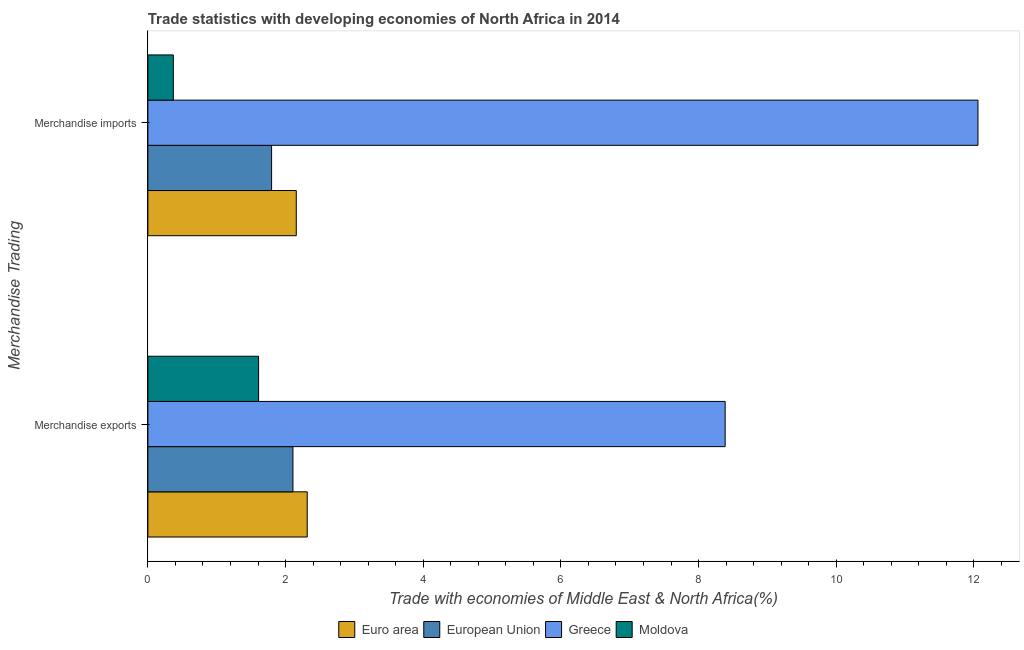How many groups of bars are there?
Offer a terse response. 2. Are the number of bars on each tick of the Y-axis equal?
Your response must be concise. Yes. How many bars are there on the 2nd tick from the bottom?
Offer a terse response. 4. What is the label of the 1st group of bars from the top?
Make the answer very short. Merchandise imports. What is the merchandise exports in European Union?
Your answer should be compact. 2.11. Across all countries, what is the maximum merchandise exports?
Provide a succinct answer. 8.39. Across all countries, what is the minimum merchandise exports?
Provide a short and direct response. 1.61. In which country was the merchandise exports minimum?
Give a very brief answer. Moldova. What is the total merchandise exports in the graph?
Keep it short and to the point. 14.42. What is the difference between the merchandise exports in Moldova and that in Greece?
Ensure brevity in your answer.  -6.78. What is the difference between the merchandise imports in Euro area and the merchandise exports in Moldova?
Keep it short and to the point. 0.55. What is the average merchandise exports per country?
Provide a succinct answer. 3.6. What is the difference between the merchandise imports and merchandise exports in European Union?
Make the answer very short. -0.31. In how many countries, is the merchandise exports greater than 0.8 %?
Provide a short and direct response. 4. What is the ratio of the merchandise exports in European Union to that in Moldova?
Make the answer very short. 1.31. Is the merchandise exports in Greece less than that in European Union?
Keep it short and to the point. No. What does the 3rd bar from the top in Merchandise imports represents?
Your response must be concise. European Union. What does the 4th bar from the bottom in Merchandise exports represents?
Give a very brief answer. Moldova. How many bars are there?
Make the answer very short. 8. Are all the bars in the graph horizontal?
Make the answer very short. Yes. What is the difference between two consecutive major ticks on the X-axis?
Give a very brief answer. 2. Are the values on the major ticks of X-axis written in scientific E-notation?
Your answer should be compact. No. Does the graph contain any zero values?
Offer a very short reply. No. Does the graph contain grids?
Make the answer very short. No. Where does the legend appear in the graph?
Provide a succinct answer. Bottom center. What is the title of the graph?
Your answer should be compact. Trade statistics with developing economies of North Africa in 2014. What is the label or title of the X-axis?
Ensure brevity in your answer.  Trade with economies of Middle East & North Africa(%). What is the label or title of the Y-axis?
Offer a terse response. Merchandise Trading. What is the Trade with economies of Middle East & North Africa(%) of Euro area in Merchandise exports?
Give a very brief answer. 2.32. What is the Trade with economies of Middle East & North Africa(%) of European Union in Merchandise exports?
Give a very brief answer. 2.11. What is the Trade with economies of Middle East & North Africa(%) in Greece in Merchandise exports?
Offer a terse response. 8.39. What is the Trade with economies of Middle East & North Africa(%) in Moldova in Merchandise exports?
Offer a terse response. 1.61. What is the Trade with economies of Middle East & North Africa(%) in Euro area in Merchandise imports?
Your answer should be compact. 2.16. What is the Trade with economies of Middle East & North Africa(%) of European Union in Merchandise imports?
Provide a short and direct response. 1.8. What is the Trade with economies of Middle East & North Africa(%) in Greece in Merchandise imports?
Provide a short and direct response. 12.06. What is the Trade with economies of Middle East & North Africa(%) in Moldova in Merchandise imports?
Make the answer very short. 0.37. Across all Merchandise Trading, what is the maximum Trade with economies of Middle East & North Africa(%) of Euro area?
Offer a very short reply. 2.32. Across all Merchandise Trading, what is the maximum Trade with economies of Middle East & North Africa(%) in European Union?
Provide a succinct answer. 2.11. Across all Merchandise Trading, what is the maximum Trade with economies of Middle East & North Africa(%) of Greece?
Your answer should be very brief. 12.06. Across all Merchandise Trading, what is the maximum Trade with economies of Middle East & North Africa(%) in Moldova?
Ensure brevity in your answer.  1.61. Across all Merchandise Trading, what is the minimum Trade with economies of Middle East & North Africa(%) in Euro area?
Provide a short and direct response. 2.16. Across all Merchandise Trading, what is the minimum Trade with economies of Middle East & North Africa(%) of European Union?
Your answer should be very brief. 1.8. Across all Merchandise Trading, what is the minimum Trade with economies of Middle East & North Africa(%) in Greece?
Ensure brevity in your answer.  8.39. Across all Merchandise Trading, what is the minimum Trade with economies of Middle East & North Africa(%) in Moldova?
Give a very brief answer. 0.37. What is the total Trade with economies of Middle East & North Africa(%) in Euro area in the graph?
Your answer should be compact. 4.47. What is the total Trade with economies of Middle East & North Africa(%) of European Union in the graph?
Ensure brevity in your answer.  3.9. What is the total Trade with economies of Middle East & North Africa(%) of Greece in the graph?
Give a very brief answer. 20.45. What is the total Trade with economies of Middle East & North Africa(%) in Moldova in the graph?
Make the answer very short. 1.98. What is the difference between the Trade with economies of Middle East & North Africa(%) in Euro area in Merchandise exports and that in Merchandise imports?
Make the answer very short. 0.16. What is the difference between the Trade with economies of Middle East & North Africa(%) in European Union in Merchandise exports and that in Merchandise imports?
Your answer should be very brief. 0.31. What is the difference between the Trade with economies of Middle East & North Africa(%) in Greece in Merchandise exports and that in Merchandise imports?
Your answer should be very brief. -3.67. What is the difference between the Trade with economies of Middle East & North Africa(%) in Moldova in Merchandise exports and that in Merchandise imports?
Provide a short and direct response. 1.24. What is the difference between the Trade with economies of Middle East & North Africa(%) of Euro area in Merchandise exports and the Trade with economies of Middle East & North Africa(%) of European Union in Merchandise imports?
Your answer should be very brief. 0.52. What is the difference between the Trade with economies of Middle East & North Africa(%) of Euro area in Merchandise exports and the Trade with economies of Middle East & North Africa(%) of Greece in Merchandise imports?
Offer a terse response. -9.74. What is the difference between the Trade with economies of Middle East & North Africa(%) in Euro area in Merchandise exports and the Trade with economies of Middle East & North Africa(%) in Moldova in Merchandise imports?
Your answer should be very brief. 1.95. What is the difference between the Trade with economies of Middle East & North Africa(%) in European Union in Merchandise exports and the Trade with economies of Middle East & North Africa(%) in Greece in Merchandise imports?
Your answer should be very brief. -9.95. What is the difference between the Trade with economies of Middle East & North Africa(%) in European Union in Merchandise exports and the Trade with economies of Middle East & North Africa(%) in Moldova in Merchandise imports?
Your answer should be compact. 1.74. What is the difference between the Trade with economies of Middle East & North Africa(%) in Greece in Merchandise exports and the Trade with economies of Middle East & North Africa(%) in Moldova in Merchandise imports?
Your response must be concise. 8.02. What is the average Trade with economies of Middle East & North Africa(%) of Euro area per Merchandise Trading?
Your answer should be compact. 2.24. What is the average Trade with economies of Middle East & North Africa(%) of European Union per Merchandise Trading?
Provide a succinct answer. 1.95. What is the average Trade with economies of Middle East & North Africa(%) in Greece per Merchandise Trading?
Give a very brief answer. 10.22. What is the average Trade with economies of Middle East & North Africa(%) in Moldova per Merchandise Trading?
Your answer should be very brief. 0.99. What is the difference between the Trade with economies of Middle East & North Africa(%) of Euro area and Trade with economies of Middle East & North Africa(%) of European Union in Merchandise exports?
Ensure brevity in your answer.  0.21. What is the difference between the Trade with economies of Middle East & North Africa(%) of Euro area and Trade with economies of Middle East & North Africa(%) of Greece in Merchandise exports?
Keep it short and to the point. -6.07. What is the difference between the Trade with economies of Middle East & North Africa(%) in Euro area and Trade with economies of Middle East & North Africa(%) in Moldova in Merchandise exports?
Offer a very short reply. 0.71. What is the difference between the Trade with economies of Middle East & North Africa(%) in European Union and Trade with economies of Middle East & North Africa(%) in Greece in Merchandise exports?
Offer a very short reply. -6.28. What is the difference between the Trade with economies of Middle East & North Africa(%) of European Union and Trade with economies of Middle East & North Africa(%) of Moldova in Merchandise exports?
Give a very brief answer. 0.5. What is the difference between the Trade with economies of Middle East & North Africa(%) of Greece and Trade with economies of Middle East & North Africa(%) of Moldova in Merchandise exports?
Keep it short and to the point. 6.78. What is the difference between the Trade with economies of Middle East & North Africa(%) in Euro area and Trade with economies of Middle East & North Africa(%) in European Union in Merchandise imports?
Offer a terse response. 0.36. What is the difference between the Trade with economies of Middle East & North Africa(%) of Euro area and Trade with economies of Middle East & North Africa(%) of Greece in Merchandise imports?
Provide a short and direct response. -9.9. What is the difference between the Trade with economies of Middle East & North Africa(%) in Euro area and Trade with economies of Middle East & North Africa(%) in Moldova in Merchandise imports?
Your answer should be very brief. 1.79. What is the difference between the Trade with economies of Middle East & North Africa(%) in European Union and Trade with economies of Middle East & North Africa(%) in Greece in Merchandise imports?
Make the answer very short. -10.26. What is the difference between the Trade with economies of Middle East & North Africa(%) in European Union and Trade with economies of Middle East & North Africa(%) in Moldova in Merchandise imports?
Offer a terse response. 1.43. What is the difference between the Trade with economies of Middle East & North Africa(%) of Greece and Trade with economies of Middle East & North Africa(%) of Moldova in Merchandise imports?
Keep it short and to the point. 11.69. What is the ratio of the Trade with economies of Middle East & North Africa(%) of Euro area in Merchandise exports to that in Merchandise imports?
Your answer should be compact. 1.07. What is the ratio of the Trade with economies of Middle East & North Africa(%) in European Union in Merchandise exports to that in Merchandise imports?
Offer a very short reply. 1.17. What is the ratio of the Trade with economies of Middle East & North Africa(%) in Greece in Merchandise exports to that in Merchandise imports?
Make the answer very short. 0.7. What is the ratio of the Trade with economies of Middle East & North Africa(%) of Moldova in Merchandise exports to that in Merchandise imports?
Ensure brevity in your answer.  4.35. What is the difference between the highest and the second highest Trade with economies of Middle East & North Africa(%) in Euro area?
Provide a succinct answer. 0.16. What is the difference between the highest and the second highest Trade with economies of Middle East & North Africa(%) in European Union?
Offer a terse response. 0.31. What is the difference between the highest and the second highest Trade with economies of Middle East & North Africa(%) in Greece?
Your answer should be very brief. 3.67. What is the difference between the highest and the second highest Trade with economies of Middle East & North Africa(%) of Moldova?
Provide a short and direct response. 1.24. What is the difference between the highest and the lowest Trade with economies of Middle East & North Africa(%) of Euro area?
Your answer should be very brief. 0.16. What is the difference between the highest and the lowest Trade with economies of Middle East & North Africa(%) of European Union?
Your answer should be very brief. 0.31. What is the difference between the highest and the lowest Trade with economies of Middle East & North Africa(%) in Greece?
Give a very brief answer. 3.67. What is the difference between the highest and the lowest Trade with economies of Middle East & North Africa(%) in Moldova?
Your response must be concise. 1.24. 